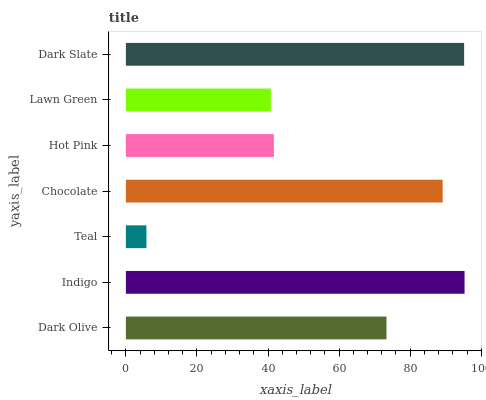Is Teal the minimum?
Answer yes or no. Yes. Is Indigo the maximum?
Answer yes or no. Yes. Is Indigo the minimum?
Answer yes or no. No. Is Teal the maximum?
Answer yes or no. No. Is Indigo greater than Teal?
Answer yes or no. Yes. Is Teal less than Indigo?
Answer yes or no. Yes. Is Teal greater than Indigo?
Answer yes or no. No. Is Indigo less than Teal?
Answer yes or no. No. Is Dark Olive the high median?
Answer yes or no. Yes. Is Dark Olive the low median?
Answer yes or no. Yes. Is Chocolate the high median?
Answer yes or no. No. Is Chocolate the low median?
Answer yes or no. No. 